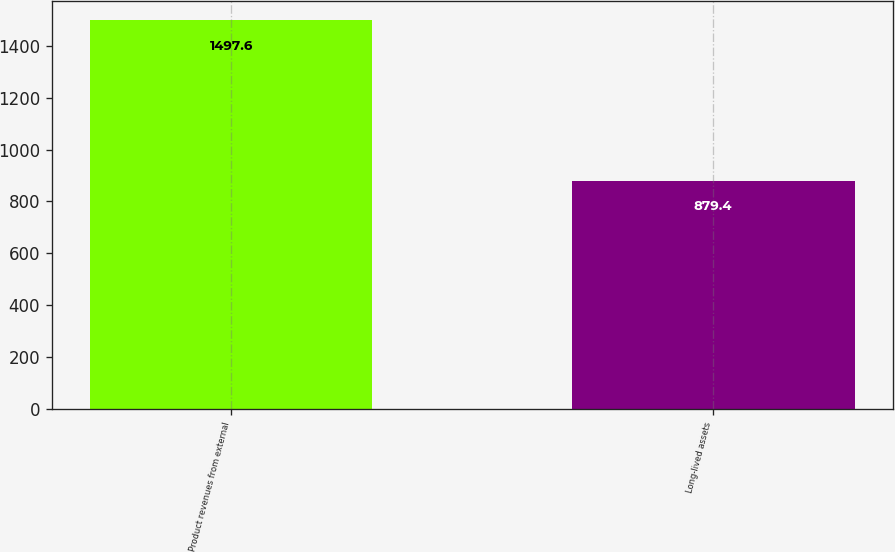Convert chart to OTSL. <chart><loc_0><loc_0><loc_500><loc_500><bar_chart><fcel>Product revenues from external<fcel>Long-lived assets<nl><fcel>1497.6<fcel>879.4<nl></chart> 